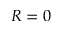Convert formula to latex. <formula><loc_0><loc_0><loc_500><loc_500>R = 0</formula> 